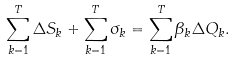Convert formula to latex. <formula><loc_0><loc_0><loc_500><loc_500>\sum _ { k = 1 } ^ { T } \Delta S _ { k } + \sum _ { k = 1 } ^ { T } \sigma _ { k } = \sum _ { k = 1 } ^ { T } \beta _ { k } \Delta Q _ { k } .</formula> 